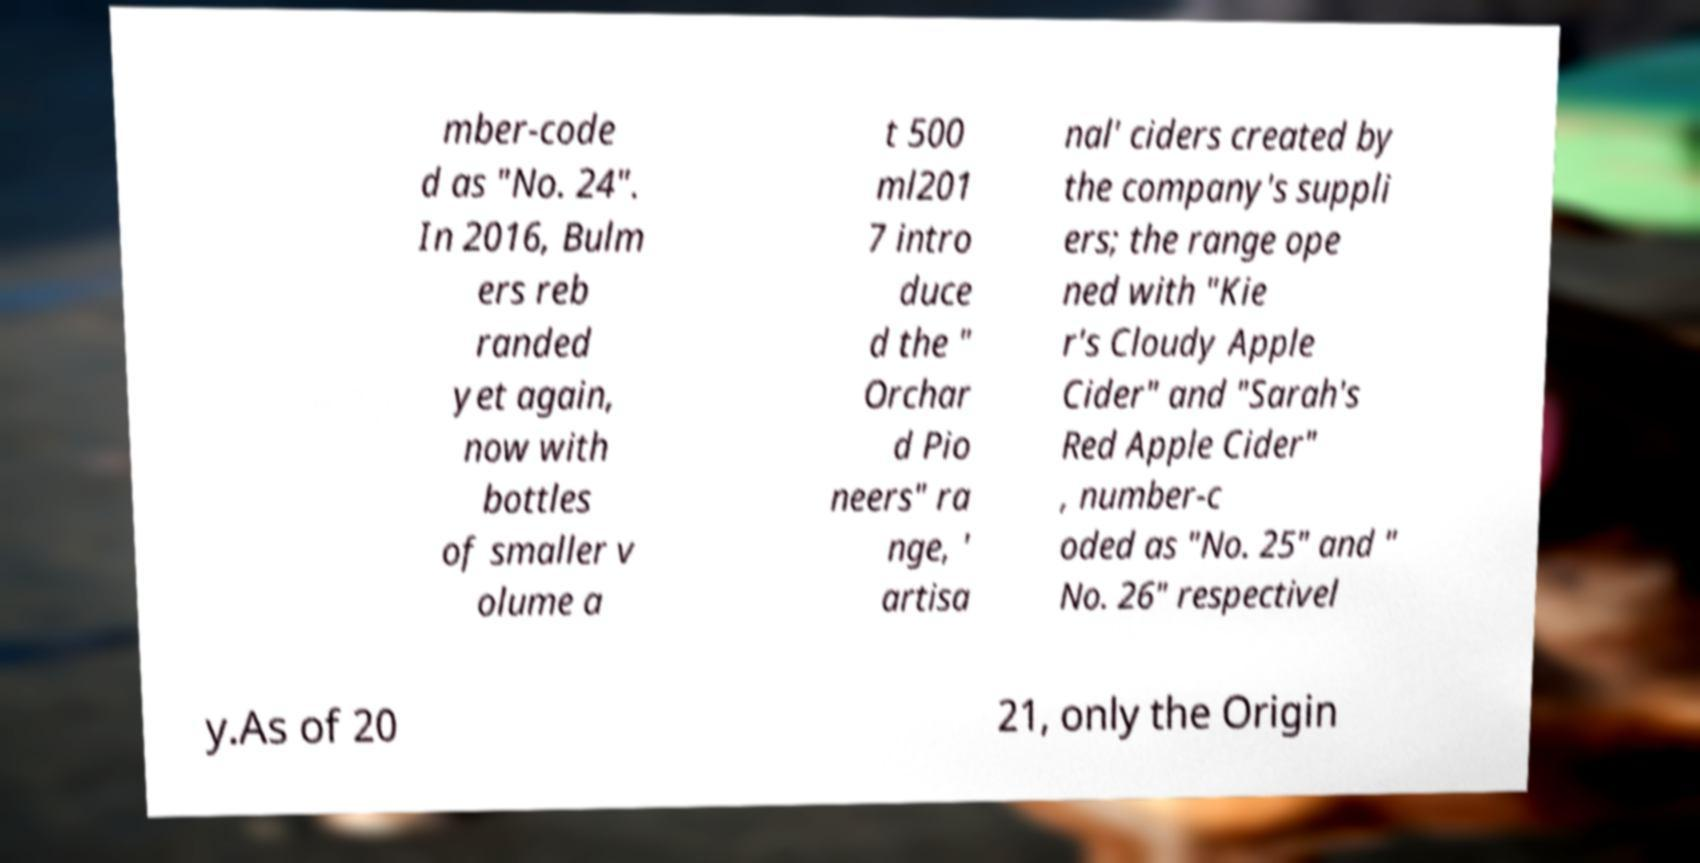Could you assist in decoding the text presented in this image and type it out clearly? mber-code d as "No. 24". In 2016, Bulm ers reb randed yet again, now with bottles of smaller v olume a t 500 ml201 7 intro duce d the " Orchar d Pio neers" ra nge, ' artisa nal' ciders created by the company's suppli ers; the range ope ned with "Kie r's Cloudy Apple Cider" and "Sarah's Red Apple Cider" , number-c oded as "No. 25" and " No. 26" respectivel y.As of 20 21, only the Origin 